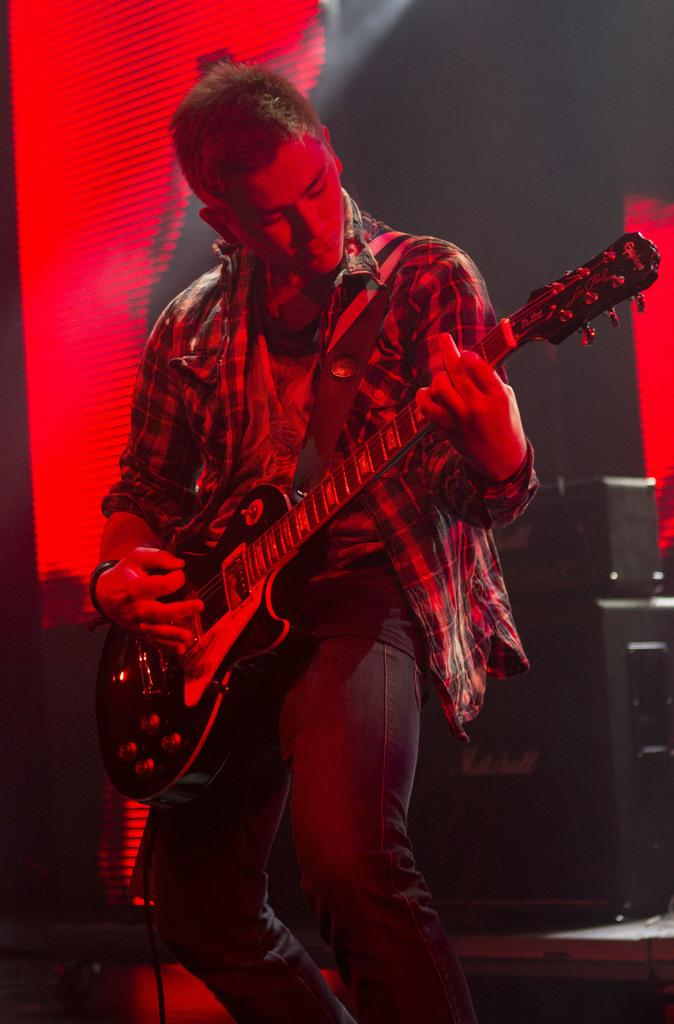What is the person in the image doing? The person is standing and playing a guitar. What can be seen in the background of the image? There is a screen in the background of the image. What object is located on the right side of the image? There is a speaker on the right side of the image. Are there any boats visible in the image? No, there are no boats present in the image. What role does the governor play in the image? There is no mention of a governor in the image or the provided facts. 